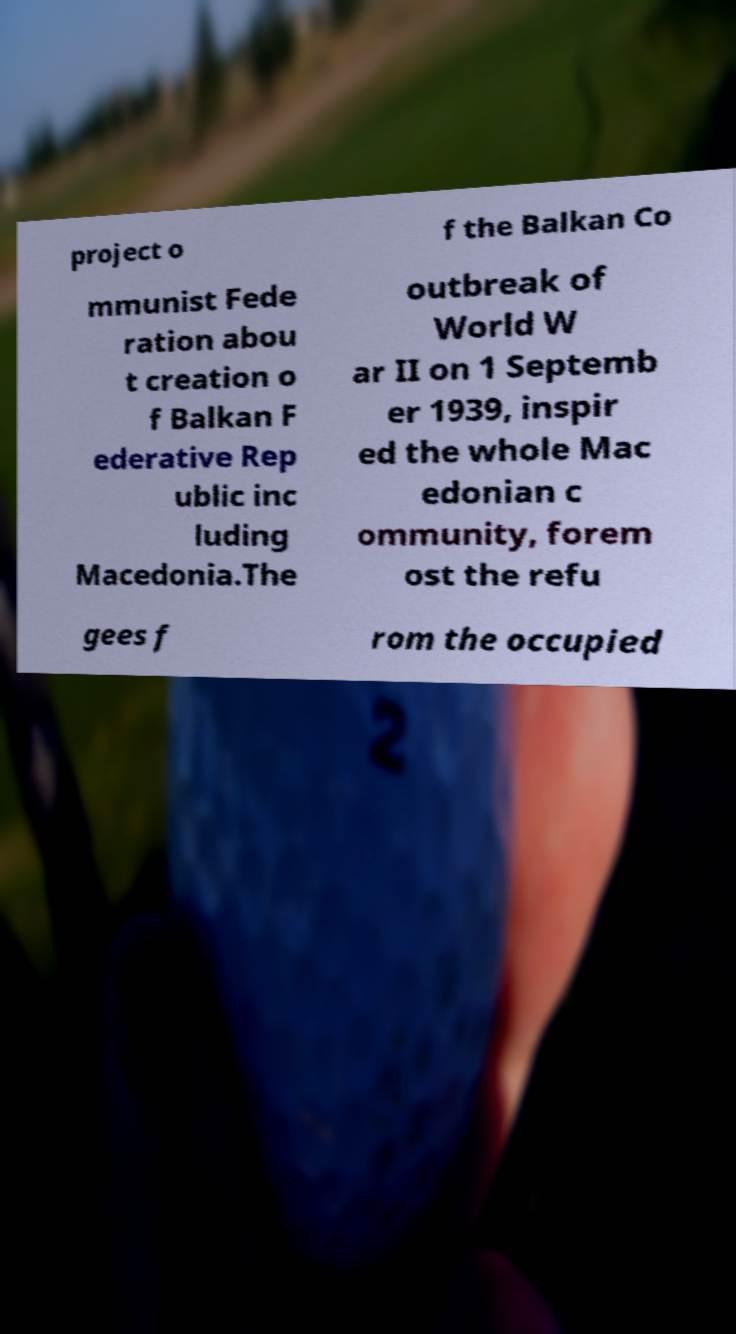There's text embedded in this image that I need extracted. Can you transcribe it verbatim? project o f the Balkan Co mmunist Fede ration abou t creation o f Balkan F ederative Rep ublic inc luding Macedonia.The outbreak of World W ar II on 1 Septemb er 1939, inspir ed the whole Mac edonian c ommunity, forem ost the refu gees f rom the occupied 